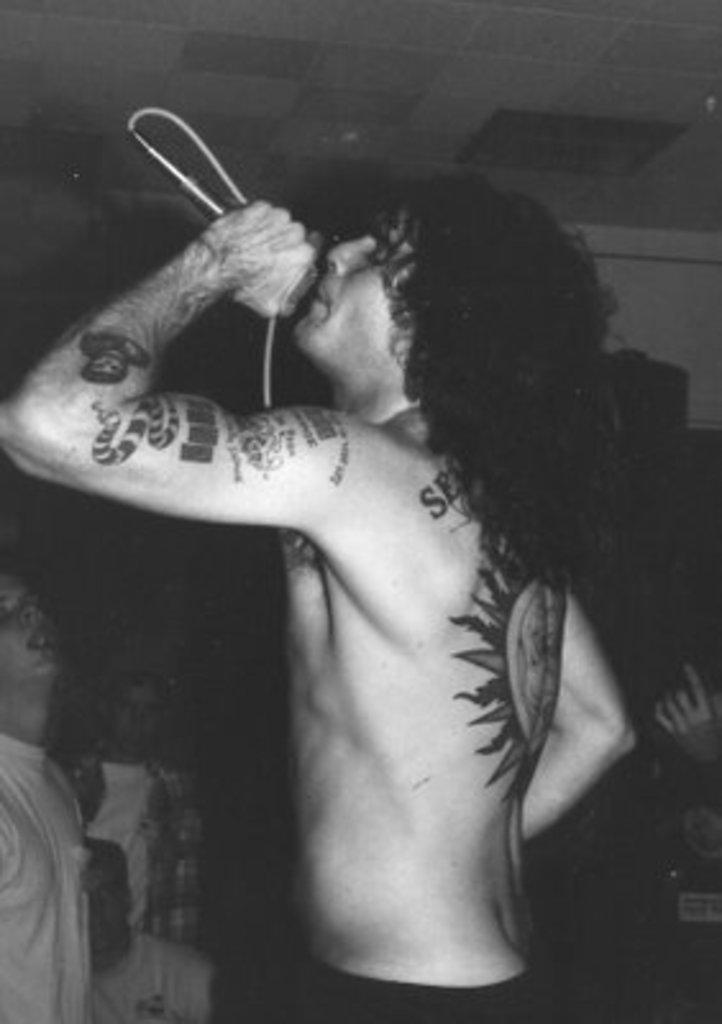What is the main subject of the image? There is a person in the image. What is the person holding in the image? The person is holding something. Can you describe any unique features of the person? The person has tattoos on their body. What can be seen in the background of the image? There is a wall visible in the image, and there are people in the background. How is the image presented in terms of color? The image is in black and white. What level of paint is required to cover the tattoos on the person's body in the image? There is no mention of paint or the need to cover tattoos in the image. The person's tattoos are visible, and the image is in black and white. 